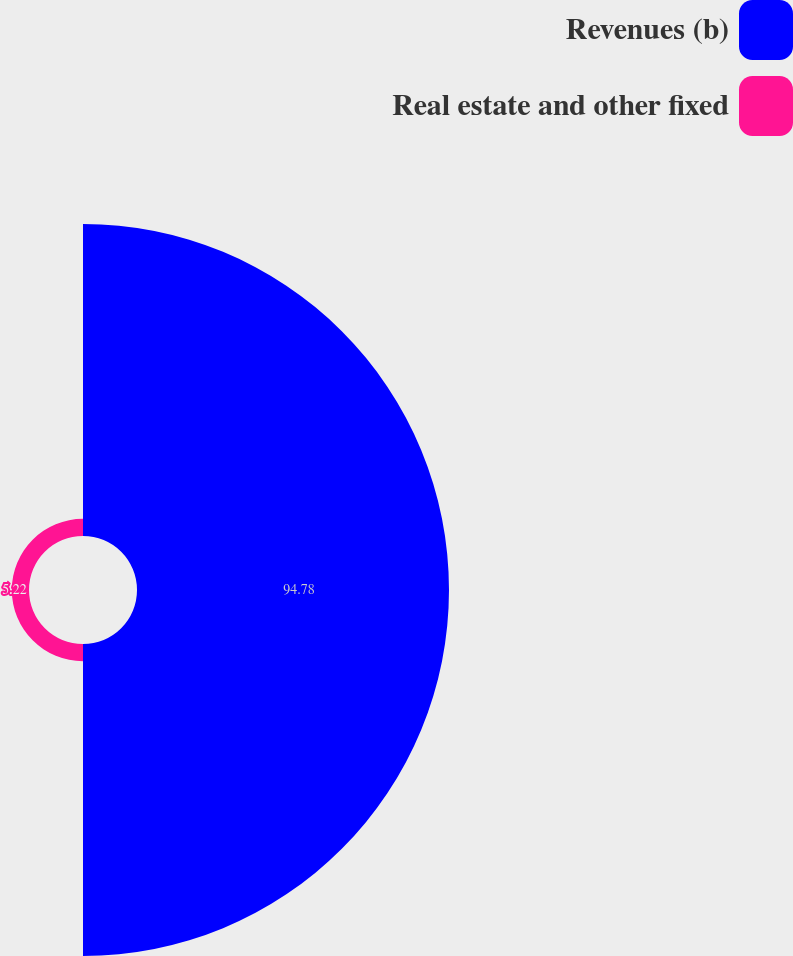Convert chart. <chart><loc_0><loc_0><loc_500><loc_500><pie_chart><fcel>Revenues (b)<fcel>Real estate and other fixed<nl><fcel>94.78%<fcel>5.22%<nl></chart> 